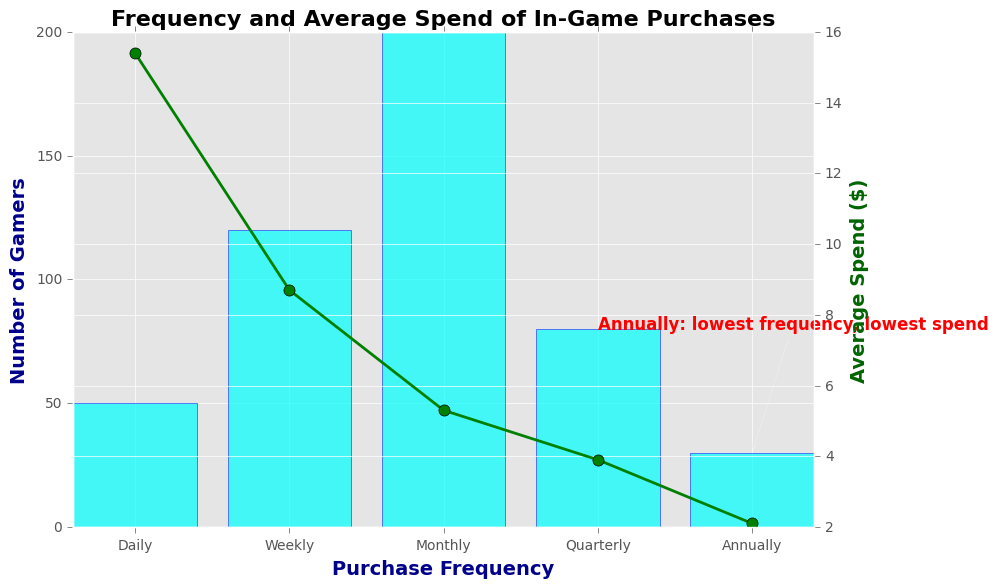What category has the highest number of gamers making in-game purchases? By inspecting the bar chart, the highest bar indicates the category with the highest number of gamers. This bar belongs to the "Monthly" category, which shows 200 gamers.
Answer: Monthly How much higher is the frequency of weekly purchases compared to quarterly purchases? The frequency of weekly purchases is 120 gamers, and for quarterly purchases, it is 80 gamers. The difference can be calculated as 120 - 80 = 40.
Answer: 40 Which category has both the lowest frequency and the lowest average spend? The annotation on the chart specifically points out that the "Annually" category has the lowest frequency (30 gamers) and the lowest average spend ($2.1).
Answer: Annually Is the average spend higher for daily purchases or weekly purchases? By examining the plotted lines, the average spend for daily purchases is 15.4 dollars, and for weekly purchases, it is 8.7 dollars. Since 15.4 is greater than 8.7, the daily spend is higher.
Answer: Daily What is the combined number of gamers making daily and annually in-game purchases? The bar chart shows that there are 50 gamers making daily purchases and 30 gamers making annually purchases. The combined number is 50 + 30 = 80.
Answer: 80 How does the average spend of monthly purchases compare to quarterly purchases? The average spend for monthly purchases is $5.3, whereas for quarterly purchases it is $3.9. Since $5.3 is greater than $3.9, monthly spend is higher.
Answer: Monthly How much greater is the average spend of daily purchases compared to annual purchases? The average spend on daily purchases is 15.4 dollars and on annual purchases is 2.1 dollars. The difference is calculated as 15.4 - 2.1 = 13.3 dollars.
Answer: 13.3 What trend can be observed in the frequency and average spend as the purchase frequency increases from annually to daily? As the purchase frequency increases from annually to daily, the frequency of purchases also increases while the average spend generally decreases. Annually has the lowest frequency and spend, whereas daily has high frequency and the highest spend.
Answer: Frequency increases, spend decreases 